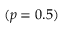<formula> <loc_0><loc_0><loc_500><loc_500>( p = 0 . 5 )</formula> 